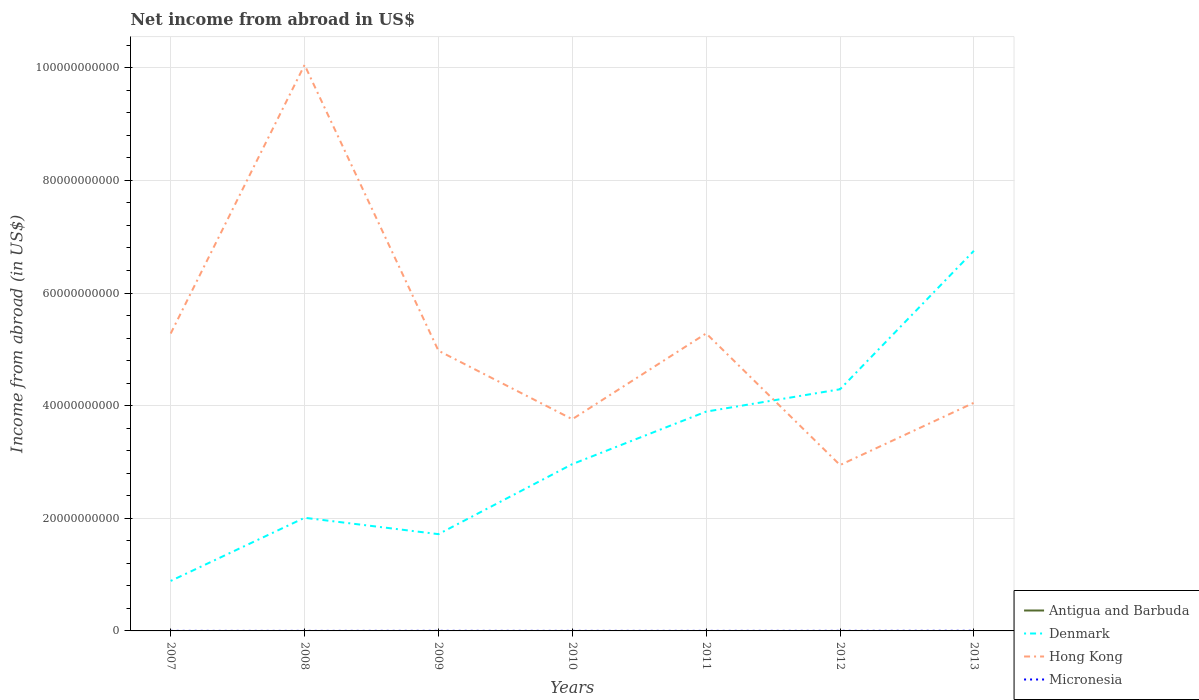Does the line corresponding to Antigua and Barbuda intersect with the line corresponding to Micronesia?
Provide a short and direct response. No. Across all years, what is the maximum net income from abroad in Antigua and Barbuda?
Provide a short and direct response. 0. What is the total net income from abroad in Hong Kong in the graph?
Offer a very short reply. 9.24e+09. What is the difference between the highest and the second highest net income from abroad in Denmark?
Your answer should be compact. 5.86e+1. Is the net income from abroad in Micronesia strictly greater than the net income from abroad in Denmark over the years?
Provide a short and direct response. Yes. How many lines are there?
Provide a succinct answer. 3. What is the difference between two consecutive major ticks on the Y-axis?
Your answer should be compact. 2.00e+1. Are the values on the major ticks of Y-axis written in scientific E-notation?
Make the answer very short. No. Where does the legend appear in the graph?
Your answer should be compact. Bottom right. How are the legend labels stacked?
Keep it short and to the point. Vertical. What is the title of the graph?
Offer a very short reply. Net income from abroad in US$. What is the label or title of the X-axis?
Your answer should be very brief. Years. What is the label or title of the Y-axis?
Keep it short and to the point. Income from abroad (in US$). What is the Income from abroad (in US$) of Denmark in 2007?
Ensure brevity in your answer.  8.88e+09. What is the Income from abroad (in US$) in Hong Kong in 2007?
Offer a terse response. 5.28e+1. What is the Income from abroad (in US$) of Micronesia in 2007?
Offer a terse response. 1.05e+07. What is the Income from abroad (in US$) of Denmark in 2008?
Ensure brevity in your answer.  2.01e+1. What is the Income from abroad (in US$) of Hong Kong in 2008?
Offer a terse response. 1.01e+11. What is the Income from abroad (in US$) in Micronesia in 2008?
Offer a very short reply. 7.36e+06. What is the Income from abroad (in US$) in Antigua and Barbuda in 2009?
Keep it short and to the point. 0. What is the Income from abroad (in US$) of Denmark in 2009?
Provide a short and direct response. 1.72e+1. What is the Income from abroad (in US$) in Hong Kong in 2009?
Your response must be concise. 4.98e+1. What is the Income from abroad (in US$) in Micronesia in 2009?
Make the answer very short. 1.69e+07. What is the Income from abroad (in US$) in Antigua and Barbuda in 2010?
Your answer should be compact. 0. What is the Income from abroad (in US$) of Denmark in 2010?
Provide a succinct answer. 2.96e+1. What is the Income from abroad (in US$) of Hong Kong in 2010?
Give a very brief answer. 3.76e+1. What is the Income from abroad (in US$) in Micronesia in 2010?
Offer a terse response. 1.10e+07. What is the Income from abroad (in US$) of Antigua and Barbuda in 2011?
Your answer should be compact. 0. What is the Income from abroad (in US$) of Denmark in 2011?
Your response must be concise. 3.89e+1. What is the Income from abroad (in US$) in Hong Kong in 2011?
Provide a short and direct response. 5.28e+1. What is the Income from abroad (in US$) in Micronesia in 2011?
Your response must be concise. 1.14e+07. What is the Income from abroad (in US$) in Antigua and Barbuda in 2012?
Your answer should be compact. 0. What is the Income from abroad (in US$) of Denmark in 2012?
Your answer should be very brief. 4.29e+1. What is the Income from abroad (in US$) of Hong Kong in 2012?
Provide a succinct answer. 2.95e+1. What is the Income from abroad (in US$) in Micronesia in 2012?
Give a very brief answer. 1.63e+07. What is the Income from abroad (in US$) of Denmark in 2013?
Provide a short and direct response. 6.75e+1. What is the Income from abroad (in US$) of Hong Kong in 2013?
Give a very brief answer. 4.05e+1. What is the Income from abroad (in US$) in Micronesia in 2013?
Your answer should be compact. 2.70e+07. Across all years, what is the maximum Income from abroad (in US$) of Denmark?
Your answer should be very brief. 6.75e+1. Across all years, what is the maximum Income from abroad (in US$) in Hong Kong?
Offer a very short reply. 1.01e+11. Across all years, what is the maximum Income from abroad (in US$) in Micronesia?
Provide a short and direct response. 2.70e+07. Across all years, what is the minimum Income from abroad (in US$) in Denmark?
Provide a succinct answer. 8.88e+09. Across all years, what is the minimum Income from abroad (in US$) of Hong Kong?
Your answer should be very brief. 2.95e+1. Across all years, what is the minimum Income from abroad (in US$) of Micronesia?
Ensure brevity in your answer.  7.36e+06. What is the total Income from abroad (in US$) in Denmark in the graph?
Your response must be concise. 2.25e+11. What is the total Income from abroad (in US$) in Hong Kong in the graph?
Keep it short and to the point. 3.63e+11. What is the total Income from abroad (in US$) in Micronesia in the graph?
Offer a terse response. 1.00e+08. What is the difference between the Income from abroad (in US$) in Denmark in 2007 and that in 2008?
Ensure brevity in your answer.  -1.12e+1. What is the difference between the Income from abroad (in US$) in Hong Kong in 2007 and that in 2008?
Your answer should be very brief. -4.77e+1. What is the difference between the Income from abroad (in US$) in Micronesia in 2007 and that in 2008?
Offer a very short reply. 3.13e+06. What is the difference between the Income from abroad (in US$) in Denmark in 2007 and that in 2009?
Provide a short and direct response. -8.31e+09. What is the difference between the Income from abroad (in US$) of Hong Kong in 2007 and that in 2009?
Give a very brief answer. 3.05e+09. What is the difference between the Income from abroad (in US$) of Micronesia in 2007 and that in 2009?
Ensure brevity in your answer.  -6.37e+06. What is the difference between the Income from abroad (in US$) of Denmark in 2007 and that in 2010?
Keep it short and to the point. -2.07e+1. What is the difference between the Income from abroad (in US$) of Hong Kong in 2007 and that in 2010?
Keep it short and to the point. 1.52e+1. What is the difference between the Income from abroad (in US$) of Micronesia in 2007 and that in 2010?
Provide a succinct answer. -4.75e+05. What is the difference between the Income from abroad (in US$) in Denmark in 2007 and that in 2011?
Provide a succinct answer. -3.01e+1. What is the difference between the Income from abroad (in US$) of Hong Kong in 2007 and that in 2011?
Give a very brief answer. -1.50e+07. What is the difference between the Income from abroad (in US$) of Micronesia in 2007 and that in 2011?
Your answer should be compact. -8.97e+05. What is the difference between the Income from abroad (in US$) in Denmark in 2007 and that in 2012?
Provide a succinct answer. -3.40e+1. What is the difference between the Income from abroad (in US$) of Hong Kong in 2007 and that in 2012?
Offer a terse response. 2.34e+1. What is the difference between the Income from abroad (in US$) of Micronesia in 2007 and that in 2012?
Make the answer very short. -5.81e+06. What is the difference between the Income from abroad (in US$) of Denmark in 2007 and that in 2013?
Make the answer very short. -5.86e+1. What is the difference between the Income from abroad (in US$) in Hong Kong in 2007 and that in 2013?
Your answer should be compact. 1.23e+1. What is the difference between the Income from abroad (in US$) of Micronesia in 2007 and that in 2013?
Ensure brevity in your answer.  -1.65e+07. What is the difference between the Income from abroad (in US$) in Denmark in 2008 and that in 2009?
Offer a terse response. 2.91e+09. What is the difference between the Income from abroad (in US$) of Hong Kong in 2008 and that in 2009?
Your answer should be very brief. 5.07e+1. What is the difference between the Income from abroad (in US$) of Micronesia in 2008 and that in 2009?
Make the answer very short. -9.50e+06. What is the difference between the Income from abroad (in US$) of Denmark in 2008 and that in 2010?
Keep it short and to the point. -9.53e+09. What is the difference between the Income from abroad (in US$) of Hong Kong in 2008 and that in 2010?
Provide a short and direct response. 6.29e+1. What is the difference between the Income from abroad (in US$) in Micronesia in 2008 and that in 2010?
Keep it short and to the point. -3.60e+06. What is the difference between the Income from abroad (in US$) of Denmark in 2008 and that in 2011?
Provide a succinct answer. -1.89e+1. What is the difference between the Income from abroad (in US$) in Hong Kong in 2008 and that in 2011?
Make the answer very short. 4.77e+1. What is the difference between the Income from abroad (in US$) of Micronesia in 2008 and that in 2011?
Give a very brief answer. -4.02e+06. What is the difference between the Income from abroad (in US$) of Denmark in 2008 and that in 2012?
Your answer should be compact. -2.28e+1. What is the difference between the Income from abroad (in US$) in Hong Kong in 2008 and that in 2012?
Your answer should be compact. 7.11e+1. What is the difference between the Income from abroad (in US$) of Micronesia in 2008 and that in 2012?
Your answer should be very brief. -8.94e+06. What is the difference between the Income from abroad (in US$) of Denmark in 2008 and that in 2013?
Your answer should be compact. -4.74e+1. What is the difference between the Income from abroad (in US$) of Hong Kong in 2008 and that in 2013?
Offer a very short reply. 6.00e+1. What is the difference between the Income from abroad (in US$) of Micronesia in 2008 and that in 2013?
Provide a succinct answer. -1.96e+07. What is the difference between the Income from abroad (in US$) in Denmark in 2009 and that in 2010?
Give a very brief answer. -1.24e+1. What is the difference between the Income from abroad (in US$) of Hong Kong in 2009 and that in 2010?
Offer a terse response. 1.22e+1. What is the difference between the Income from abroad (in US$) of Micronesia in 2009 and that in 2010?
Your response must be concise. 5.90e+06. What is the difference between the Income from abroad (in US$) of Denmark in 2009 and that in 2011?
Your answer should be compact. -2.18e+1. What is the difference between the Income from abroad (in US$) in Hong Kong in 2009 and that in 2011?
Offer a very short reply. -3.06e+09. What is the difference between the Income from abroad (in US$) in Micronesia in 2009 and that in 2011?
Your answer should be very brief. 5.48e+06. What is the difference between the Income from abroad (in US$) in Denmark in 2009 and that in 2012?
Your answer should be compact. -2.57e+1. What is the difference between the Income from abroad (in US$) of Hong Kong in 2009 and that in 2012?
Make the answer very short. 2.03e+1. What is the difference between the Income from abroad (in US$) of Micronesia in 2009 and that in 2012?
Make the answer very short. 5.60e+05. What is the difference between the Income from abroad (in US$) in Denmark in 2009 and that in 2013?
Ensure brevity in your answer.  -5.03e+1. What is the difference between the Income from abroad (in US$) of Hong Kong in 2009 and that in 2013?
Your response must be concise. 9.24e+09. What is the difference between the Income from abroad (in US$) of Micronesia in 2009 and that in 2013?
Your answer should be compact. -1.01e+07. What is the difference between the Income from abroad (in US$) in Denmark in 2010 and that in 2011?
Ensure brevity in your answer.  -9.33e+09. What is the difference between the Income from abroad (in US$) of Hong Kong in 2010 and that in 2011?
Offer a terse response. -1.52e+1. What is the difference between the Income from abroad (in US$) of Micronesia in 2010 and that in 2011?
Offer a very short reply. -4.22e+05. What is the difference between the Income from abroad (in US$) in Denmark in 2010 and that in 2012?
Offer a terse response. -1.33e+1. What is the difference between the Income from abroad (in US$) in Hong Kong in 2010 and that in 2012?
Offer a very short reply. 8.14e+09. What is the difference between the Income from abroad (in US$) in Micronesia in 2010 and that in 2012?
Give a very brief answer. -5.34e+06. What is the difference between the Income from abroad (in US$) of Denmark in 2010 and that in 2013?
Keep it short and to the point. -3.79e+1. What is the difference between the Income from abroad (in US$) of Hong Kong in 2010 and that in 2013?
Your response must be concise. -2.92e+09. What is the difference between the Income from abroad (in US$) in Micronesia in 2010 and that in 2013?
Offer a terse response. -1.60e+07. What is the difference between the Income from abroad (in US$) of Denmark in 2011 and that in 2012?
Provide a short and direct response. -3.97e+09. What is the difference between the Income from abroad (in US$) in Hong Kong in 2011 and that in 2012?
Ensure brevity in your answer.  2.34e+1. What is the difference between the Income from abroad (in US$) of Micronesia in 2011 and that in 2012?
Offer a terse response. -4.92e+06. What is the difference between the Income from abroad (in US$) in Denmark in 2011 and that in 2013?
Provide a short and direct response. -2.86e+1. What is the difference between the Income from abroad (in US$) in Hong Kong in 2011 and that in 2013?
Your response must be concise. 1.23e+1. What is the difference between the Income from abroad (in US$) of Micronesia in 2011 and that in 2013?
Offer a terse response. -1.56e+07. What is the difference between the Income from abroad (in US$) in Denmark in 2012 and that in 2013?
Ensure brevity in your answer.  -2.46e+1. What is the difference between the Income from abroad (in US$) of Hong Kong in 2012 and that in 2013?
Keep it short and to the point. -1.11e+1. What is the difference between the Income from abroad (in US$) in Micronesia in 2012 and that in 2013?
Provide a short and direct response. -1.07e+07. What is the difference between the Income from abroad (in US$) in Denmark in 2007 and the Income from abroad (in US$) in Hong Kong in 2008?
Provide a succinct answer. -9.16e+1. What is the difference between the Income from abroad (in US$) of Denmark in 2007 and the Income from abroad (in US$) of Micronesia in 2008?
Ensure brevity in your answer.  8.87e+09. What is the difference between the Income from abroad (in US$) of Hong Kong in 2007 and the Income from abroad (in US$) of Micronesia in 2008?
Offer a very short reply. 5.28e+1. What is the difference between the Income from abroad (in US$) of Denmark in 2007 and the Income from abroad (in US$) of Hong Kong in 2009?
Your answer should be compact. -4.09e+1. What is the difference between the Income from abroad (in US$) in Denmark in 2007 and the Income from abroad (in US$) in Micronesia in 2009?
Ensure brevity in your answer.  8.86e+09. What is the difference between the Income from abroad (in US$) of Hong Kong in 2007 and the Income from abroad (in US$) of Micronesia in 2009?
Provide a succinct answer. 5.28e+1. What is the difference between the Income from abroad (in US$) in Denmark in 2007 and the Income from abroad (in US$) in Hong Kong in 2010?
Offer a terse response. -2.87e+1. What is the difference between the Income from abroad (in US$) in Denmark in 2007 and the Income from abroad (in US$) in Micronesia in 2010?
Your answer should be very brief. 8.87e+09. What is the difference between the Income from abroad (in US$) in Hong Kong in 2007 and the Income from abroad (in US$) in Micronesia in 2010?
Ensure brevity in your answer.  5.28e+1. What is the difference between the Income from abroad (in US$) in Denmark in 2007 and the Income from abroad (in US$) in Hong Kong in 2011?
Make the answer very short. -4.39e+1. What is the difference between the Income from abroad (in US$) of Denmark in 2007 and the Income from abroad (in US$) of Micronesia in 2011?
Your answer should be very brief. 8.87e+09. What is the difference between the Income from abroad (in US$) of Hong Kong in 2007 and the Income from abroad (in US$) of Micronesia in 2011?
Provide a short and direct response. 5.28e+1. What is the difference between the Income from abroad (in US$) in Denmark in 2007 and the Income from abroad (in US$) in Hong Kong in 2012?
Offer a very short reply. -2.06e+1. What is the difference between the Income from abroad (in US$) in Denmark in 2007 and the Income from abroad (in US$) in Micronesia in 2012?
Keep it short and to the point. 8.86e+09. What is the difference between the Income from abroad (in US$) of Hong Kong in 2007 and the Income from abroad (in US$) of Micronesia in 2012?
Make the answer very short. 5.28e+1. What is the difference between the Income from abroad (in US$) of Denmark in 2007 and the Income from abroad (in US$) of Hong Kong in 2013?
Offer a very short reply. -3.16e+1. What is the difference between the Income from abroad (in US$) in Denmark in 2007 and the Income from abroad (in US$) in Micronesia in 2013?
Your response must be concise. 8.85e+09. What is the difference between the Income from abroad (in US$) in Hong Kong in 2007 and the Income from abroad (in US$) in Micronesia in 2013?
Make the answer very short. 5.28e+1. What is the difference between the Income from abroad (in US$) of Denmark in 2008 and the Income from abroad (in US$) of Hong Kong in 2009?
Your answer should be compact. -2.97e+1. What is the difference between the Income from abroad (in US$) of Denmark in 2008 and the Income from abroad (in US$) of Micronesia in 2009?
Provide a succinct answer. 2.01e+1. What is the difference between the Income from abroad (in US$) in Hong Kong in 2008 and the Income from abroad (in US$) in Micronesia in 2009?
Your answer should be very brief. 1.00e+11. What is the difference between the Income from abroad (in US$) in Denmark in 2008 and the Income from abroad (in US$) in Hong Kong in 2010?
Make the answer very short. -1.75e+1. What is the difference between the Income from abroad (in US$) in Denmark in 2008 and the Income from abroad (in US$) in Micronesia in 2010?
Offer a terse response. 2.01e+1. What is the difference between the Income from abroad (in US$) of Hong Kong in 2008 and the Income from abroad (in US$) of Micronesia in 2010?
Your answer should be compact. 1.00e+11. What is the difference between the Income from abroad (in US$) of Denmark in 2008 and the Income from abroad (in US$) of Hong Kong in 2011?
Make the answer very short. -3.27e+1. What is the difference between the Income from abroad (in US$) of Denmark in 2008 and the Income from abroad (in US$) of Micronesia in 2011?
Give a very brief answer. 2.01e+1. What is the difference between the Income from abroad (in US$) in Hong Kong in 2008 and the Income from abroad (in US$) in Micronesia in 2011?
Your answer should be very brief. 1.00e+11. What is the difference between the Income from abroad (in US$) in Denmark in 2008 and the Income from abroad (in US$) in Hong Kong in 2012?
Your answer should be very brief. -9.36e+09. What is the difference between the Income from abroad (in US$) of Denmark in 2008 and the Income from abroad (in US$) of Micronesia in 2012?
Offer a very short reply. 2.01e+1. What is the difference between the Income from abroad (in US$) of Hong Kong in 2008 and the Income from abroad (in US$) of Micronesia in 2012?
Offer a terse response. 1.00e+11. What is the difference between the Income from abroad (in US$) in Denmark in 2008 and the Income from abroad (in US$) in Hong Kong in 2013?
Offer a very short reply. -2.04e+1. What is the difference between the Income from abroad (in US$) of Denmark in 2008 and the Income from abroad (in US$) of Micronesia in 2013?
Make the answer very short. 2.01e+1. What is the difference between the Income from abroad (in US$) in Hong Kong in 2008 and the Income from abroad (in US$) in Micronesia in 2013?
Provide a short and direct response. 1.00e+11. What is the difference between the Income from abroad (in US$) in Denmark in 2009 and the Income from abroad (in US$) in Hong Kong in 2010?
Your response must be concise. -2.04e+1. What is the difference between the Income from abroad (in US$) in Denmark in 2009 and the Income from abroad (in US$) in Micronesia in 2010?
Give a very brief answer. 1.72e+1. What is the difference between the Income from abroad (in US$) of Hong Kong in 2009 and the Income from abroad (in US$) of Micronesia in 2010?
Provide a succinct answer. 4.98e+1. What is the difference between the Income from abroad (in US$) in Denmark in 2009 and the Income from abroad (in US$) in Hong Kong in 2011?
Provide a short and direct response. -3.56e+1. What is the difference between the Income from abroad (in US$) of Denmark in 2009 and the Income from abroad (in US$) of Micronesia in 2011?
Provide a succinct answer. 1.72e+1. What is the difference between the Income from abroad (in US$) in Hong Kong in 2009 and the Income from abroad (in US$) in Micronesia in 2011?
Your answer should be very brief. 4.98e+1. What is the difference between the Income from abroad (in US$) of Denmark in 2009 and the Income from abroad (in US$) of Hong Kong in 2012?
Provide a short and direct response. -1.23e+1. What is the difference between the Income from abroad (in US$) of Denmark in 2009 and the Income from abroad (in US$) of Micronesia in 2012?
Provide a succinct answer. 1.72e+1. What is the difference between the Income from abroad (in US$) in Hong Kong in 2009 and the Income from abroad (in US$) in Micronesia in 2012?
Offer a very short reply. 4.97e+1. What is the difference between the Income from abroad (in US$) of Denmark in 2009 and the Income from abroad (in US$) of Hong Kong in 2013?
Ensure brevity in your answer.  -2.33e+1. What is the difference between the Income from abroad (in US$) in Denmark in 2009 and the Income from abroad (in US$) in Micronesia in 2013?
Provide a succinct answer. 1.72e+1. What is the difference between the Income from abroad (in US$) of Hong Kong in 2009 and the Income from abroad (in US$) of Micronesia in 2013?
Your response must be concise. 4.97e+1. What is the difference between the Income from abroad (in US$) of Denmark in 2010 and the Income from abroad (in US$) of Hong Kong in 2011?
Offer a terse response. -2.32e+1. What is the difference between the Income from abroad (in US$) in Denmark in 2010 and the Income from abroad (in US$) in Micronesia in 2011?
Make the answer very short. 2.96e+1. What is the difference between the Income from abroad (in US$) in Hong Kong in 2010 and the Income from abroad (in US$) in Micronesia in 2011?
Offer a terse response. 3.76e+1. What is the difference between the Income from abroad (in US$) of Denmark in 2010 and the Income from abroad (in US$) of Hong Kong in 2012?
Provide a succinct answer. 1.64e+08. What is the difference between the Income from abroad (in US$) of Denmark in 2010 and the Income from abroad (in US$) of Micronesia in 2012?
Your response must be concise. 2.96e+1. What is the difference between the Income from abroad (in US$) in Hong Kong in 2010 and the Income from abroad (in US$) in Micronesia in 2012?
Your response must be concise. 3.76e+1. What is the difference between the Income from abroad (in US$) of Denmark in 2010 and the Income from abroad (in US$) of Hong Kong in 2013?
Provide a succinct answer. -1.09e+1. What is the difference between the Income from abroad (in US$) in Denmark in 2010 and the Income from abroad (in US$) in Micronesia in 2013?
Keep it short and to the point. 2.96e+1. What is the difference between the Income from abroad (in US$) of Hong Kong in 2010 and the Income from abroad (in US$) of Micronesia in 2013?
Your answer should be compact. 3.76e+1. What is the difference between the Income from abroad (in US$) in Denmark in 2011 and the Income from abroad (in US$) in Hong Kong in 2012?
Provide a short and direct response. 9.49e+09. What is the difference between the Income from abroad (in US$) in Denmark in 2011 and the Income from abroad (in US$) in Micronesia in 2012?
Offer a very short reply. 3.89e+1. What is the difference between the Income from abroad (in US$) of Hong Kong in 2011 and the Income from abroad (in US$) of Micronesia in 2012?
Provide a succinct answer. 5.28e+1. What is the difference between the Income from abroad (in US$) of Denmark in 2011 and the Income from abroad (in US$) of Hong Kong in 2013?
Keep it short and to the point. -1.57e+09. What is the difference between the Income from abroad (in US$) in Denmark in 2011 and the Income from abroad (in US$) in Micronesia in 2013?
Provide a short and direct response. 3.89e+1. What is the difference between the Income from abroad (in US$) in Hong Kong in 2011 and the Income from abroad (in US$) in Micronesia in 2013?
Provide a short and direct response. 5.28e+1. What is the difference between the Income from abroad (in US$) of Denmark in 2012 and the Income from abroad (in US$) of Hong Kong in 2013?
Offer a very short reply. 2.39e+09. What is the difference between the Income from abroad (in US$) in Denmark in 2012 and the Income from abroad (in US$) in Micronesia in 2013?
Ensure brevity in your answer.  4.29e+1. What is the difference between the Income from abroad (in US$) of Hong Kong in 2012 and the Income from abroad (in US$) of Micronesia in 2013?
Give a very brief answer. 2.94e+1. What is the average Income from abroad (in US$) in Antigua and Barbuda per year?
Your response must be concise. 0. What is the average Income from abroad (in US$) in Denmark per year?
Keep it short and to the point. 3.22e+1. What is the average Income from abroad (in US$) in Hong Kong per year?
Provide a short and direct response. 5.19e+1. What is the average Income from abroad (in US$) of Micronesia per year?
Keep it short and to the point. 1.43e+07. In the year 2007, what is the difference between the Income from abroad (in US$) of Denmark and Income from abroad (in US$) of Hong Kong?
Your response must be concise. -4.39e+1. In the year 2007, what is the difference between the Income from abroad (in US$) of Denmark and Income from abroad (in US$) of Micronesia?
Provide a short and direct response. 8.87e+09. In the year 2007, what is the difference between the Income from abroad (in US$) in Hong Kong and Income from abroad (in US$) in Micronesia?
Your answer should be compact. 5.28e+1. In the year 2008, what is the difference between the Income from abroad (in US$) of Denmark and Income from abroad (in US$) of Hong Kong?
Ensure brevity in your answer.  -8.04e+1. In the year 2008, what is the difference between the Income from abroad (in US$) of Denmark and Income from abroad (in US$) of Micronesia?
Keep it short and to the point. 2.01e+1. In the year 2008, what is the difference between the Income from abroad (in US$) in Hong Kong and Income from abroad (in US$) in Micronesia?
Make the answer very short. 1.00e+11. In the year 2009, what is the difference between the Income from abroad (in US$) in Denmark and Income from abroad (in US$) in Hong Kong?
Provide a short and direct response. -3.26e+1. In the year 2009, what is the difference between the Income from abroad (in US$) in Denmark and Income from abroad (in US$) in Micronesia?
Your answer should be compact. 1.72e+1. In the year 2009, what is the difference between the Income from abroad (in US$) in Hong Kong and Income from abroad (in US$) in Micronesia?
Your response must be concise. 4.97e+1. In the year 2010, what is the difference between the Income from abroad (in US$) of Denmark and Income from abroad (in US$) of Hong Kong?
Give a very brief answer. -7.98e+09. In the year 2010, what is the difference between the Income from abroad (in US$) in Denmark and Income from abroad (in US$) in Micronesia?
Provide a short and direct response. 2.96e+1. In the year 2010, what is the difference between the Income from abroad (in US$) of Hong Kong and Income from abroad (in US$) of Micronesia?
Offer a terse response. 3.76e+1. In the year 2011, what is the difference between the Income from abroad (in US$) in Denmark and Income from abroad (in US$) in Hong Kong?
Your answer should be compact. -1.39e+1. In the year 2011, what is the difference between the Income from abroad (in US$) in Denmark and Income from abroad (in US$) in Micronesia?
Your answer should be very brief. 3.89e+1. In the year 2011, what is the difference between the Income from abroad (in US$) in Hong Kong and Income from abroad (in US$) in Micronesia?
Offer a terse response. 5.28e+1. In the year 2012, what is the difference between the Income from abroad (in US$) in Denmark and Income from abroad (in US$) in Hong Kong?
Keep it short and to the point. 1.35e+1. In the year 2012, what is the difference between the Income from abroad (in US$) of Denmark and Income from abroad (in US$) of Micronesia?
Keep it short and to the point. 4.29e+1. In the year 2012, what is the difference between the Income from abroad (in US$) in Hong Kong and Income from abroad (in US$) in Micronesia?
Your response must be concise. 2.94e+1. In the year 2013, what is the difference between the Income from abroad (in US$) in Denmark and Income from abroad (in US$) in Hong Kong?
Ensure brevity in your answer.  2.70e+1. In the year 2013, what is the difference between the Income from abroad (in US$) in Denmark and Income from abroad (in US$) in Micronesia?
Give a very brief answer. 6.75e+1. In the year 2013, what is the difference between the Income from abroad (in US$) in Hong Kong and Income from abroad (in US$) in Micronesia?
Your answer should be compact. 4.05e+1. What is the ratio of the Income from abroad (in US$) of Denmark in 2007 to that in 2008?
Provide a succinct answer. 0.44. What is the ratio of the Income from abroad (in US$) in Hong Kong in 2007 to that in 2008?
Ensure brevity in your answer.  0.53. What is the ratio of the Income from abroad (in US$) in Micronesia in 2007 to that in 2008?
Make the answer very short. 1.42. What is the ratio of the Income from abroad (in US$) in Denmark in 2007 to that in 2009?
Your answer should be very brief. 0.52. What is the ratio of the Income from abroad (in US$) in Hong Kong in 2007 to that in 2009?
Offer a very short reply. 1.06. What is the ratio of the Income from abroad (in US$) in Micronesia in 2007 to that in 2009?
Your answer should be very brief. 0.62. What is the ratio of the Income from abroad (in US$) of Denmark in 2007 to that in 2010?
Make the answer very short. 0.3. What is the ratio of the Income from abroad (in US$) in Hong Kong in 2007 to that in 2010?
Provide a succinct answer. 1.4. What is the ratio of the Income from abroad (in US$) of Micronesia in 2007 to that in 2010?
Keep it short and to the point. 0.96. What is the ratio of the Income from abroad (in US$) of Denmark in 2007 to that in 2011?
Make the answer very short. 0.23. What is the ratio of the Income from abroad (in US$) in Micronesia in 2007 to that in 2011?
Give a very brief answer. 0.92. What is the ratio of the Income from abroad (in US$) in Denmark in 2007 to that in 2012?
Offer a terse response. 0.21. What is the ratio of the Income from abroad (in US$) of Hong Kong in 2007 to that in 2012?
Keep it short and to the point. 1.79. What is the ratio of the Income from abroad (in US$) in Micronesia in 2007 to that in 2012?
Make the answer very short. 0.64. What is the ratio of the Income from abroad (in US$) of Denmark in 2007 to that in 2013?
Offer a terse response. 0.13. What is the ratio of the Income from abroad (in US$) of Hong Kong in 2007 to that in 2013?
Ensure brevity in your answer.  1.3. What is the ratio of the Income from abroad (in US$) of Micronesia in 2007 to that in 2013?
Ensure brevity in your answer.  0.39. What is the ratio of the Income from abroad (in US$) of Denmark in 2008 to that in 2009?
Offer a very short reply. 1.17. What is the ratio of the Income from abroad (in US$) of Hong Kong in 2008 to that in 2009?
Your response must be concise. 2.02. What is the ratio of the Income from abroad (in US$) of Micronesia in 2008 to that in 2009?
Your answer should be very brief. 0.44. What is the ratio of the Income from abroad (in US$) in Denmark in 2008 to that in 2010?
Keep it short and to the point. 0.68. What is the ratio of the Income from abroad (in US$) in Hong Kong in 2008 to that in 2010?
Offer a terse response. 2.67. What is the ratio of the Income from abroad (in US$) in Micronesia in 2008 to that in 2010?
Ensure brevity in your answer.  0.67. What is the ratio of the Income from abroad (in US$) of Denmark in 2008 to that in 2011?
Provide a succinct answer. 0.52. What is the ratio of the Income from abroad (in US$) of Hong Kong in 2008 to that in 2011?
Your answer should be compact. 1.9. What is the ratio of the Income from abroad (in US$) of Micronesia in 2008 to that in 2011?
Provide a succinct answer. 0.65. What is the ratio of the Income from abroad (in US$) in Denmark in 2008 to that in 2012?
Provide a short and direct response. 0.47. What is the ratio of the Income from abroad (in US$) of Hong Kong in 2008 to that in 2012?
Ensure brevity in your answer.  3.41. What is the ratio of the Income from abroad (in US$) in Micronesia in 2008 to that in 2012?
Provide a succinct answer. 0.45. What is the ratio of the Income from abroad (in US$) in Denmark in 2008 to that in 2013?
Give a very brief answer. 0.3. What is the ratio of the Income from abroad (in US$) of Hong Kong in 2008 to that in 2013?
Provide a succinct answer. 2.48. What is the ratio of the Income from abroad (in US$) of Micronesia in 2008 to that in 2013?
Give a very brief answer. 0.27. What is the ratio of the Income from abroad (in US$) of Denmark in 2009 to that in 2010?
Make the answer very short. 0.58. What is the ratio of the Income from abroad (in US$) of Hong Kong in 2009 to that in 2010?
Provide a succinct answer. 1.32. What is the ratio of the Income from abroad (in US$) in Micronesia in 2009 to that in 2010?
Make the answer very short. 1.54. What is the ratio of the Income from abroad (in US$) of Denmark in 2009 to that in 2011?
Your response must be concise. 0.44. What is the ratio of the Income from abroad (in US$) in Hong Kong in 2009 to that in 2011?
Provide a succinct answer. 0.94. What is the ratio of the Income from abroad (in US$) in Micronesia in 2009 to that in 2011?
Your answer should be very brief. 1.48. What is the ratio of the Income from abroad (in US$) in Denmark in 2009 to that in 2012?
Offer a terse response. 0.4. What is the ratio of the Income from abroad (in US$) in Hong Kong in 2009 to that in 2012?
Keep it short and to the point. 1.69. What is the ratio of the Income from abroad (in US$) of Micronesia in 2009 to that in 2012?
Keep it short and to the point. 1.03. What is the ratio of the Income from abroad (in US$) of Denmark in 2009 to that in 2013?
Provide a short and direct response. 0.25. What is the ratio of the Income from abroad (in US$) of Hong Kong in 2009 to that in 2013?
Make the answer very short. 1.23. What is the ratio of the Income from abroad (in US$) in Micronesia in 2009 to that in 2013?
Provide a succinct answer. 0.62. What is the ratio of the Income from abroad (in US$) in Denmark in 2010 to that in 2011?
Your answer should be compact. 0.76. What is the ratio of the Income from abroad (in US$) of Hong Kong in 2010 to that in 2011?
Provide a short and direct response. 0.71. What is the ratio of the Income from abroad (in US$) in Micronesia in 2010 to that in 2011?
Keep it short and to the point. 0.96. What is the ratio of the Income from abroad (in US$) in Denmark in 2010 to that in 2012?
Give a very brief answer. 0.69. What is the ratio of the Income from abroad (in US$) of Hong Kong in 2010 to that in 2012?
Your answer should be very brief. 1.28. What is the ratio of the Income from abroad (in US$) of Micronesia in 2010 to that in 2012?
Your answer should be compact. 0.67. What is the ratio of the Income from abroad (in US$) of Denmark in 2010 to that in 2013?
Offer a terse response. 0.44. What is the ratio of the Income from abroad (in US$) in Hong Kong in 2010 to that in 2013?
Ensure brevity in your answer.  0.93. What is the ratio of the Income from abroad (in US$) of Micronesia in 2010 to that in 2013?
Offer a very short reply. 0.41. What is the ratio of the Income from abroad (in US$) in Denmark in 2011 to that in 2012?
Your answer should be very brief. 0.91. What is the ratio of the Income from abroad (in US$) of Hong Kong in 2011 to that in 2012?
Ensure brevity in your answer.  1.79. What is the ratio of the Income from abroad (in US$) in Micronesia in 2011 to that in 2012?
Ensure brevity in your answer.  0.7. What is the ratio of the Income from abroad (in US$) of Denmark in 2011 to that in 2013?
Your answer should be compact. 0.58. What is the ratio of the Income from abroad (in US$) of Hong Kong in 2011 to that in 2013?
Offer a terse response. 1.3. What is the ratio of the Income from abroad (in US$) in Micronesia in 2011 to that in 2013?
Provide a short and direct response. 0.42. What is the ratio of the Income from abroad (in US$) of Denmark in 2012 to that in 2013?
Your answer should be compact. 0.64. What is the ratio of the Income from abroad (in US$) in Hong Kong in 2012 to that in 2013?
Your answer should be very brief. 0.73. What is the ratio of the Income from abroad (in US$) of Micronesia in 2012 to that in 2013?
Give a very brief answer. 0.6. What is the difference between the highest and the second highest Income from abroad (in US$) in Denmark?
Your response must be concise. 2.46e+1. What is the difference between the highest and the second highest Income from abroad (in US$) in Hong Kong?
Give a very brief answer. 4.77e+1. What is the difference between the highest and the second highest Income from abroad (in US$) of Micronesia?
Your response must be concise. 1.01e+07. What is the difference between the highest and the lowest Income from abroad (in US$) of Denmark?
Your response must be concise. 5.86e+1. What is the difference between the highest and the lowest Income from abroad (in US$) in Hong Kong?
Keep it short and to the point. 7.11e+1. What is the difference between the highest and the lowest Income from abroad (in US$) in Micronesia?
Your response must be concise. 1.96e+07. 